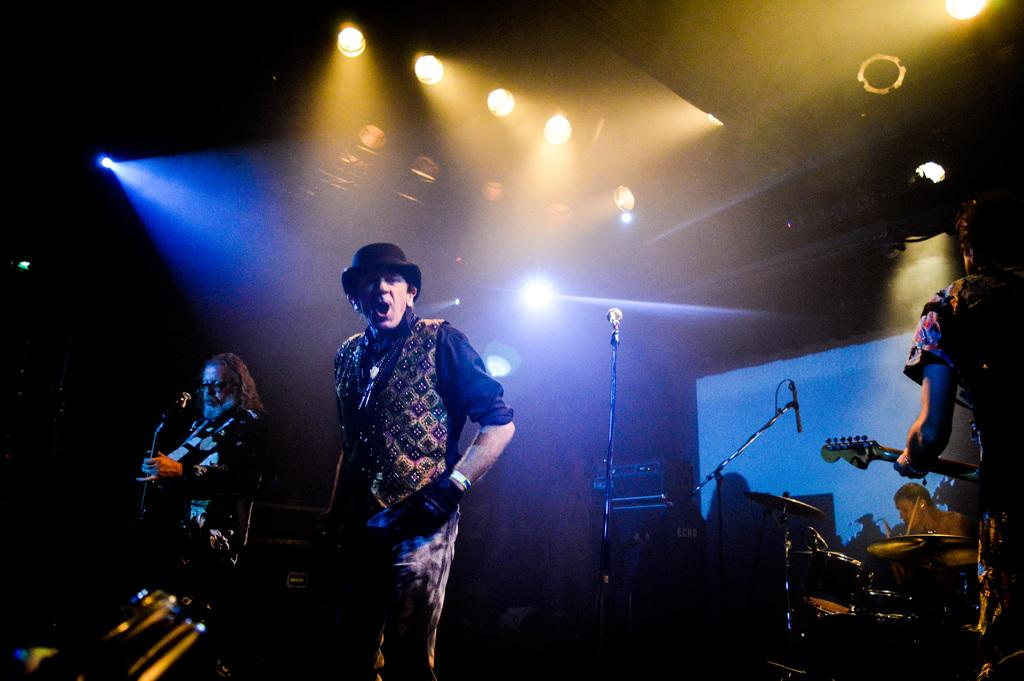What type of lights are visible in the image? There are focusing lights in the image. What is the person in the image doing? A person is singing in the image. What instrument is the person playing in the image? A person is playing guitar in the image. What else can be seen in the image related to music? There are musical instruments being played in the image, and a microphone with a holder is present. Can you tell me how many fowl are flying in the image? There are no fowl visible in the image; it features focusing lights, a person singing, a person playing guitar, musical instruments, and a microphone with a holder. 